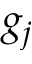<formula> <loc_0><loc_0><loc_500><loc_500>g _ { j }</formula> 